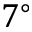<formula> <loc_0><loc_0><loc_500><loc_500>7 ^ { \circ }</formula> 